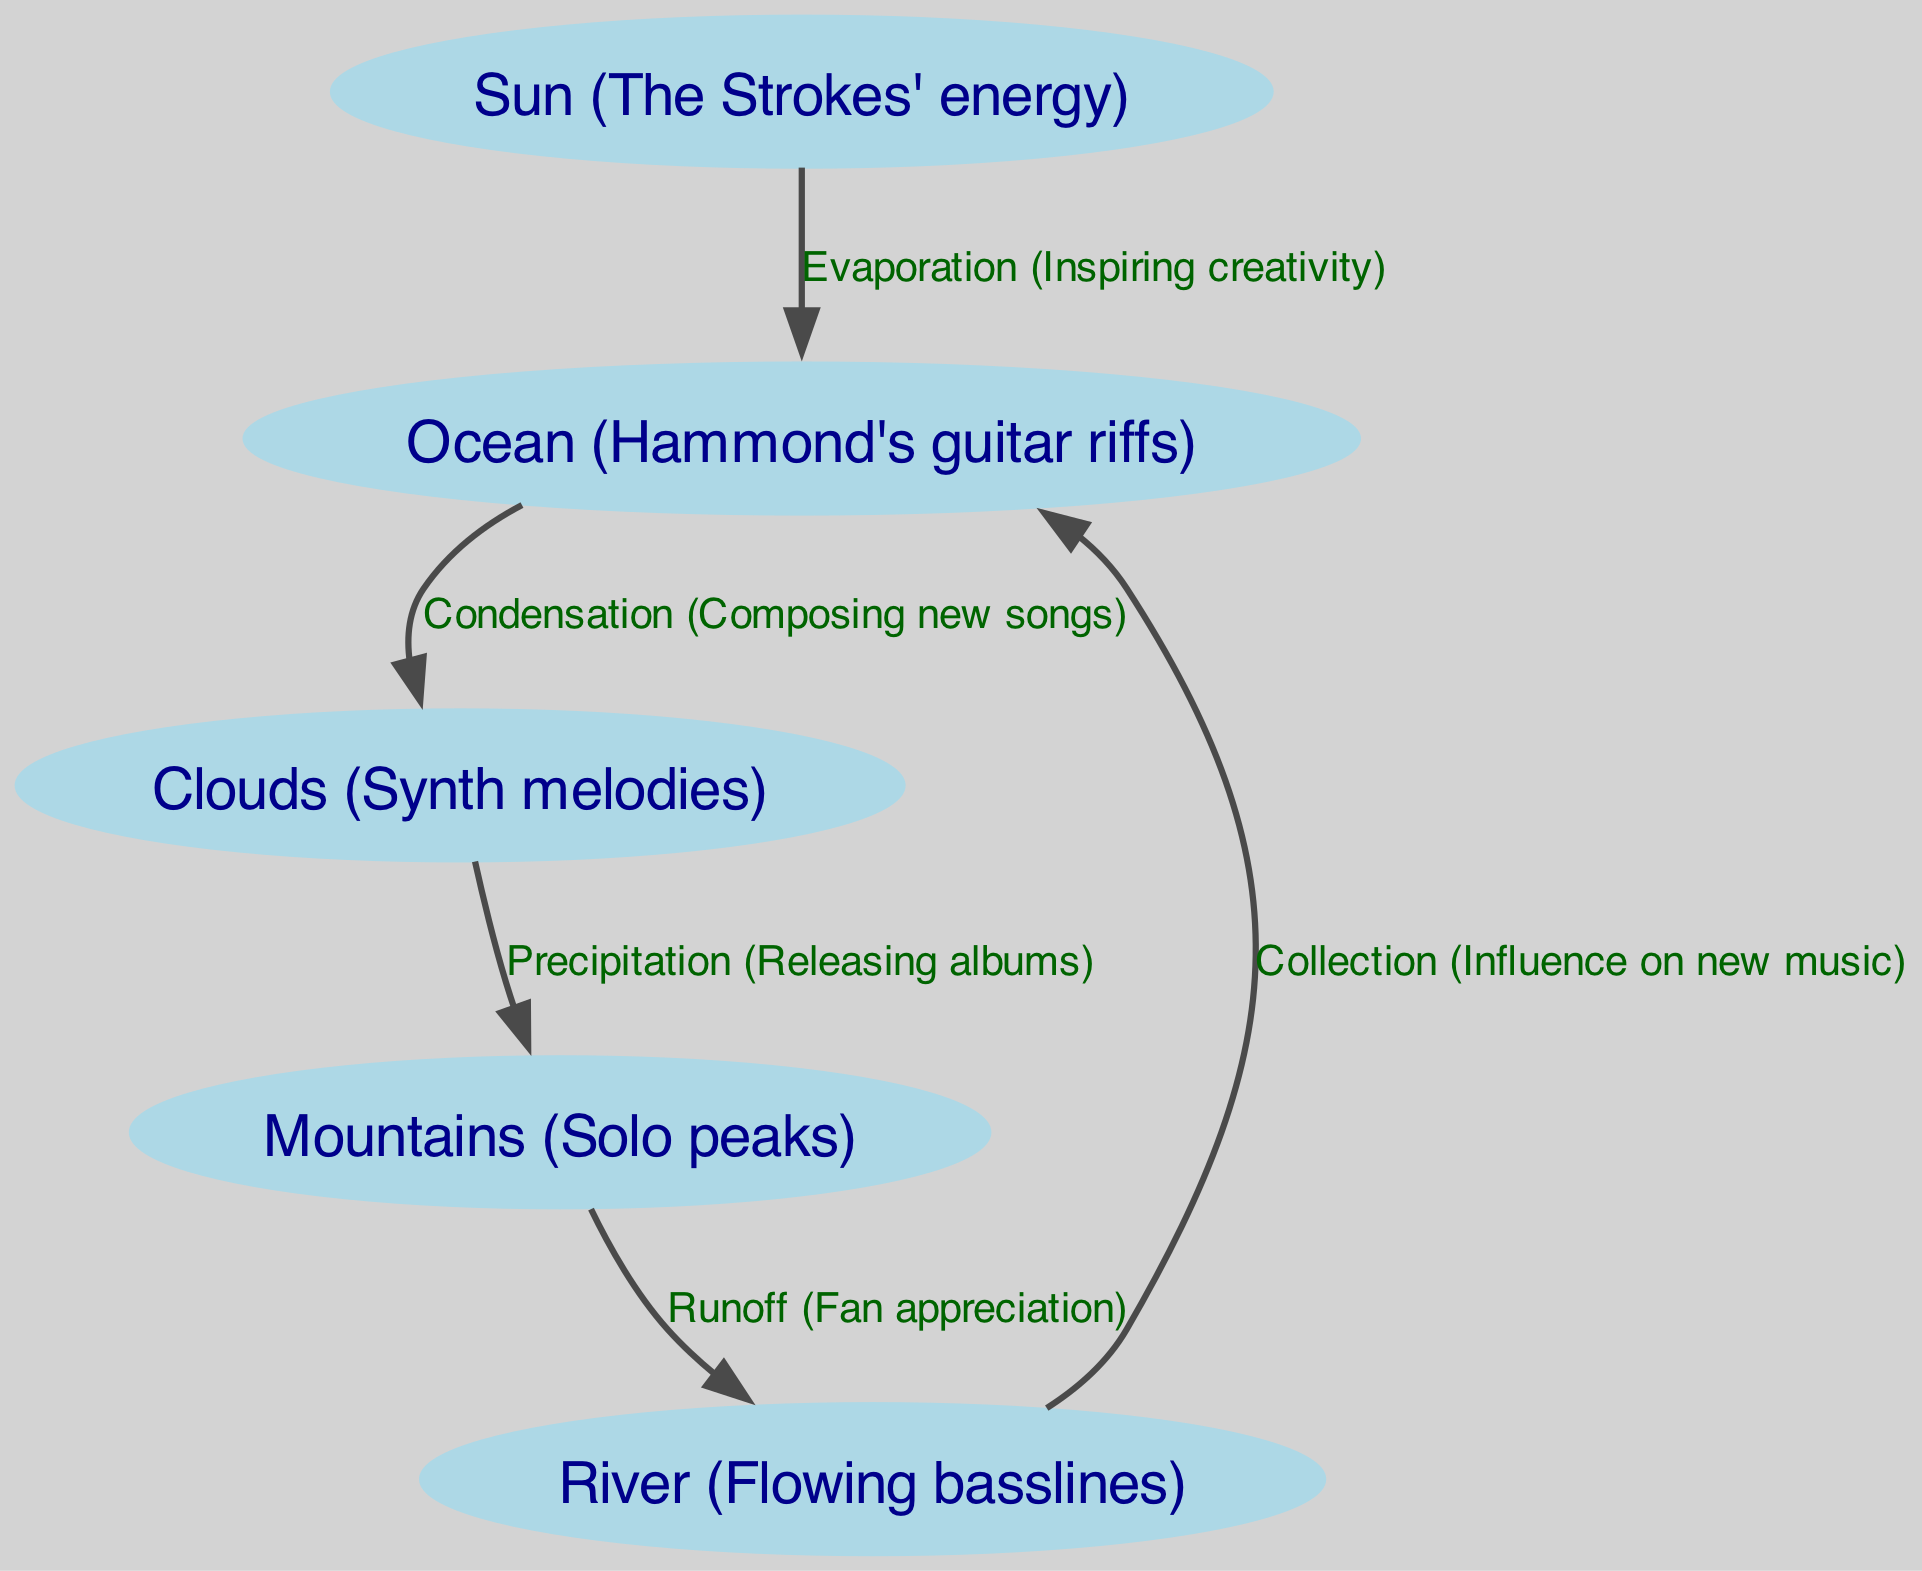What is the first process in the water cycle represented in the diagram? The diagram indicates that the first process is "Evaporation," which connects the "Sun" and "Ocean" nodes.
Answer: Evaporation How many nodes are present in the diagram? By counting the nodes labeled as "Sun," "Ocean," "Clouds," "Mountains," and "River," we find there are a total of 5 nodes.
Answer: 5 Which process is represented between the "Clouds" and "Mountains"? The edge connecting "Clouds" to "Mountains" is labeled as "Precipitation," indicating the process occurring between them.
Answer: Precipitation What do the "River" and "Ocean" nodes represent in terms of flow direction? The flow direction is indicated by the edge labeled "Collection," showing that the "River" feeds back into the "Ocean," completing the cycle.
Answer: Collection How does "Condensation" contribute to the process of music creation in this diagram? The diagram connects "Ocean" to "Clouds" through "Condensation," suggesting that this process, akin to composing new songs, is critical in the flow from water to clouds.
Answer: Composing new songs What does "Runoff" signify in relation to "Mountains" and "River"? The edge labeled "Runoff" between "Mountains" and "River" signifies how precipitation collected on mountains eventually flows down to form rivers.
Answer: Fan appreciation Which node is influenced by "River" through the process labeled as "Collection"? The "Ocean" node is influenced by the "River," indicating this part of the cycle where water collects back into the ocean.
Answer: Ocean What musical element does "Sun" represent in this diagram? The "Sun" node is described as "The Strokes' energy," representing the source of energy that initiates the water cycle process.
Answer: The Strokes' energy 